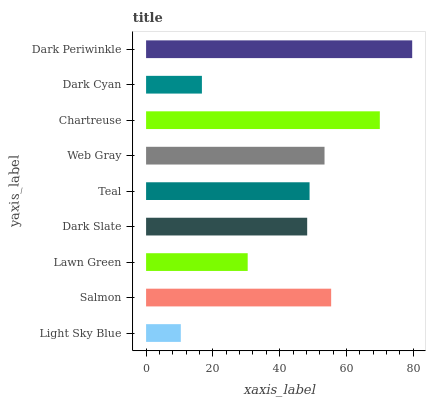Is Light Sky Blue the minimum?
Answer yes or no. Yes. Is Dark Periwinkle the maximum?
Answer yes or no. Yes. Is Salmon the minimum?
Answer yes or no. No. Is Salmon the maximum?
Answer yes or no. No. Is Salmon greater than Light Sky Blue?
Answer yes or no. Yes. Is Light Sky Blue less than Salmon?
Answer yes or no. Yes. Is Light Sky Blue greater than Salmon?
Answer yes or no. No. Is Salmon less than Light Sky Blue?
Answer yes or no. No. Is Teal the high median?
Answer yes or no. Yes. Is Teal the low median?
Answer yes or no. Yes. Is Dark Slate the high median?
Answer yes or no. No. Is Dark Periwinkle the low median?
Answer yes or no. No. 